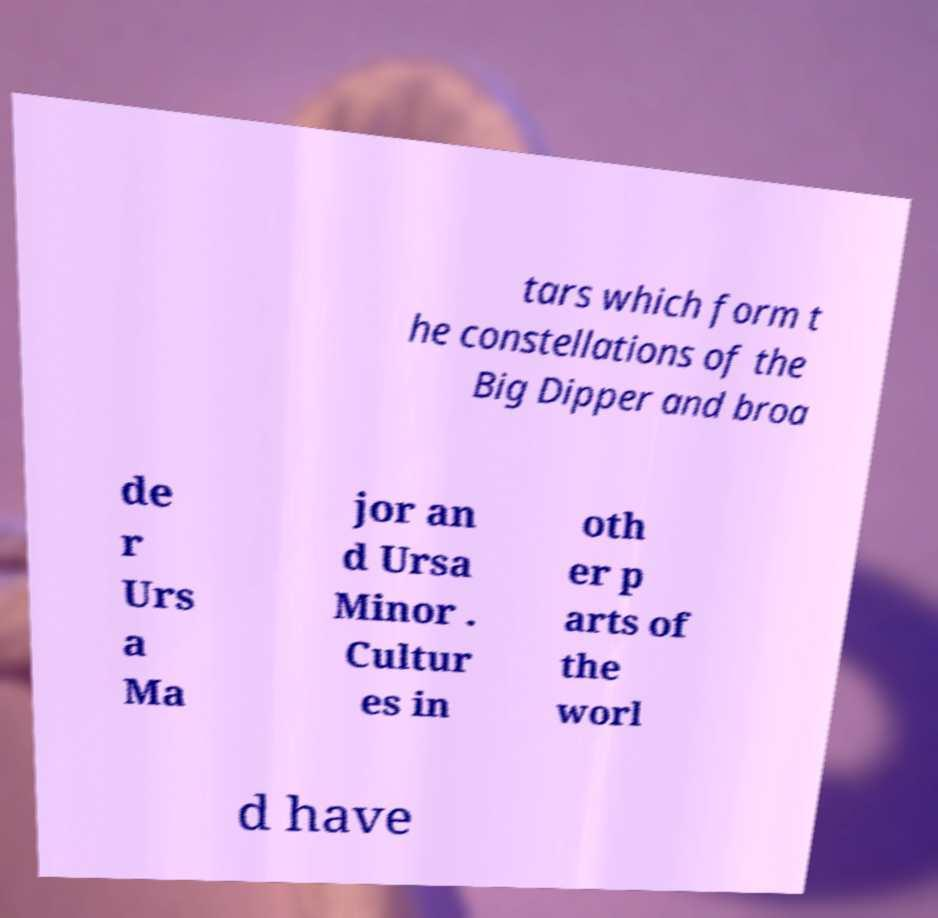Could you assist in decoding the text presented in this image and type it out clearly? tars which form t he constellations of the Big Dipper and broa de r Urs a Ma jor an d Ursa Minor . Cultur es in oth er p arts of the worl d have 